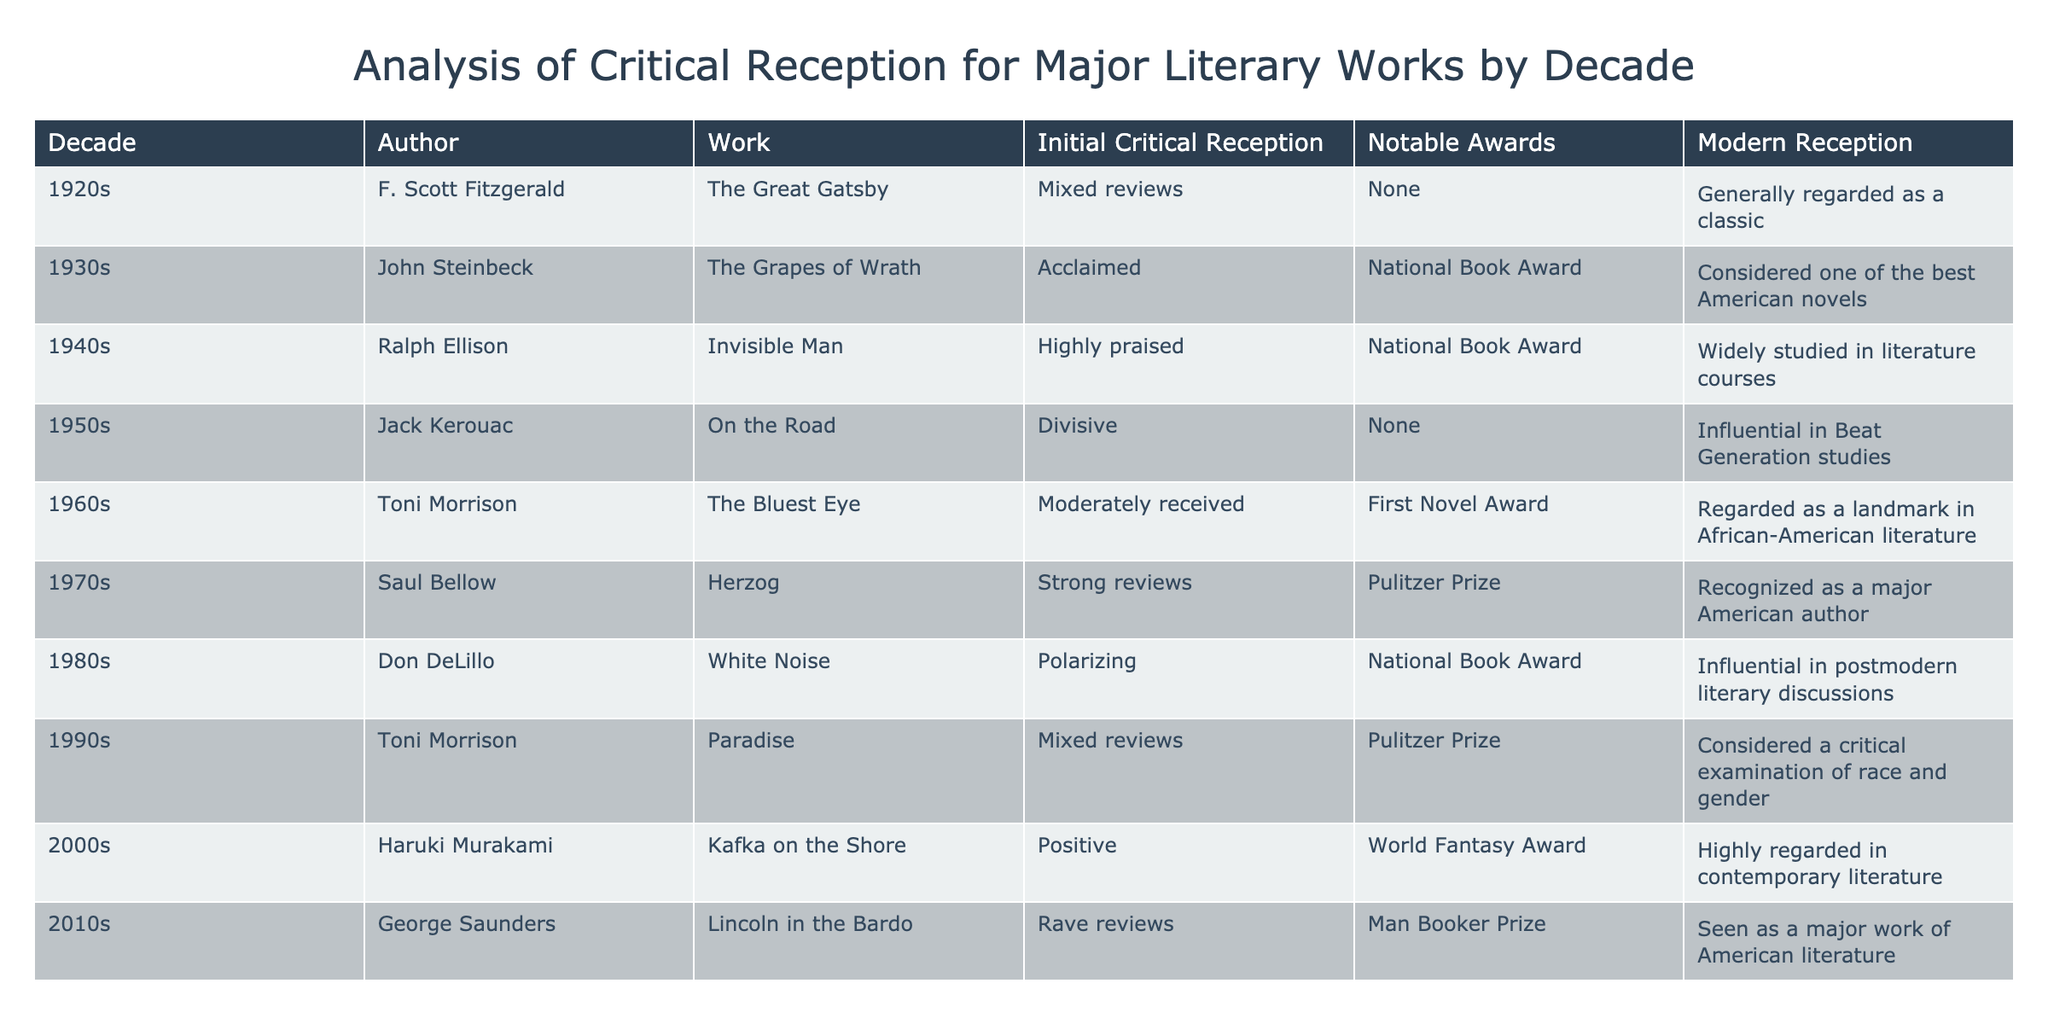What was the initial critical reception of "The Bluest Eye"? The table shows the initial critical reception for "The Bluest Eye" by Toni Morrison as "Moderately received." Therefore, the answer is derived directly from the corresponding row for the 1960s.
Answer: Moderately received Which work received the National Book Award in the 1940s? According to the table, "Invisible Man" by Ralph Ellison received the National Book Award during the 1940s. This is verified by locating the corresponding entry in the table.
Answer: Invisible Man How many works listed received a Pulitzer Prize? Counting the entries in the table, both "Herzog" by Saul Bellow and "Paradise" by Toni Morrison received the Pulitzer Prize. Since there are two distinct instances of Pulitzer winners in the table, the total is two.
Answer: 2 Was "On the Road" by Jack Kerouac highly praised upon its release? From the table, it indicates that "On the Road" received divisive reviews initially. Thus, the fact that it was not highly praised can be confirmed by checking the critical reception in the corresponding entry.
Answer: No What decade had the highest number of works that received notable awards? By analyzing the table rows, we find that the 1990s features two works that received notable awards ("Paradise" and "White Noise"). Since no other decade matches this count in terms of notable awards, it is concluded that the 1990s had the highest.
Answer: 1990s Which author had works that were received both acclaim and mixed reviews, and what were the respective works? The table indicates that John Steinbeck's "The Grapes of Wrath" was acclaimed and Toni Morrison’s "Paradise" received mixed reviews. To confirm, we examine each author's entry and list the works correspondingly.
Answer: John Steinbeck: The Grapes of Wrath, Toni Morrison: Paradise What is the modern perception of "Kafka on the Shore"? From the table, the modern reception of "Kafka on the Shore" by Haruki Murakami is described as "Highly regarded in contemporary literature." This is stated in the respective row for the 2000s, confirming the modern perception.
Answer: Highly regarded in contemporary literature What significant shift can be observed in the reception of Toni Morrison's works over the decades? Analyzing the entries, "The Bluest Eye" (1960s) was moderately received, while "Paradise" (1990s) received mixed reviews. This indicates a fluctuation in critical reception, reflecting how perceptions of her works evolved over time, as illustrated by the entries in the table.
Answer: Fluctuation in critical reception 